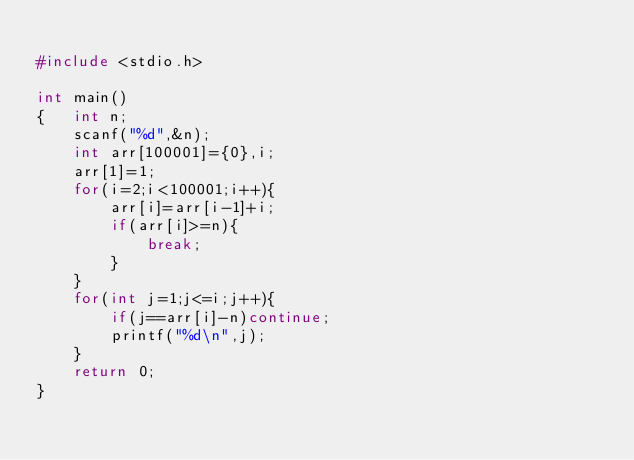<code> <loc_0><loc_0><loc_500><loc_500><_C_>
#include <stdio.h>

int main()
{   int n;
    scanf("%d",&n);
    int arr[100001]={0},i;
    arr[1]=1;
    for(i=2;i<100001;i++){
        arr[i]=arr[i-1]+i;
        if(arr[i]>=n){
            break;
        }
    }
    for(int j=1;j<=i;j++){
        if(j==arr[i]-n)continue;
        printf("%d\n",j);
    }
    return 0;
}
</code> 